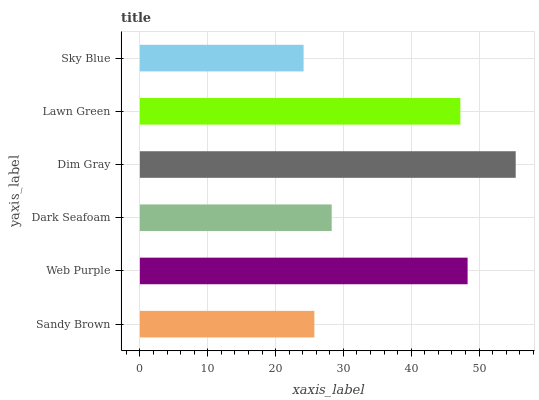Is Sky Blue the minimum?
Answer yes or no. Yes. Is Dim Gray the maximum?
Answer yes or no. Yes. Is Web Purple the minimum?
Answer yes or no. No. Is Web Purple the maximum?
Answer yes or no. No. Is Web Purple greater than Sandy Brown?
Answer yes or no. Yes. Is Sandy Brown less than Web Purple?
Answer yes or no. Yes. Is Sandy Brown greater than Web Purple?
Answer yes or no. No. Is Web Purple less than Sandy Brown?
Answer yes or no. No. Is Lawn Green the high median?
Answer yes or no. Yes. Is Dark Seafoam the low median?
Answer yes or no. Yes. Is Sky Blue the high median?
Answer yes or no. No. Is Dim Gray the low median?
Answer yes or no. No. 